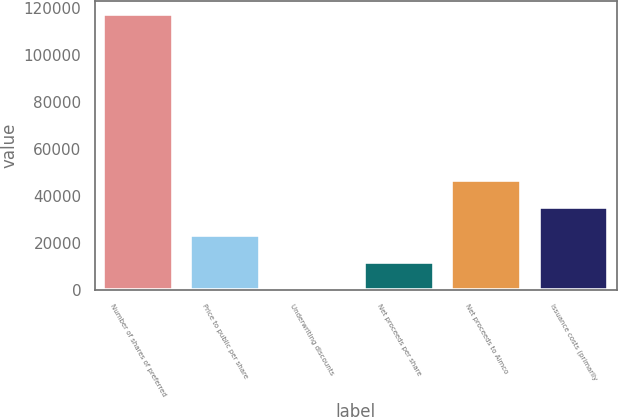Convert chart to OTSL. <chart><loc_0><loc_0><loc_500><loc_500><bar_chart><fcel>Number of shares of preferred<fcel>Price to public per share<fcel>Underwriting discounts<fcel>Net proceeds per share<fcel>Net proceeds to Aimco<fcel>Issuance costs (primarily<nl><fcel>117400<fcel>23480.4<fcel>0.51<fcel>11740.5<fcel>46960.3<fcel>35220.4<nl></chart> 